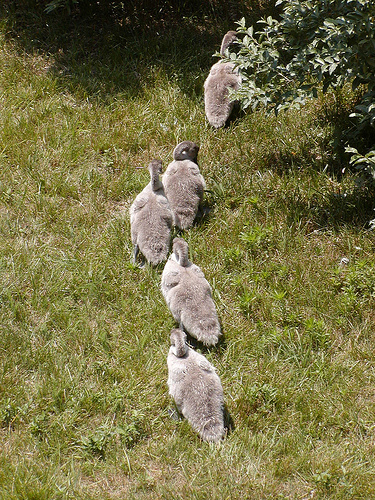<image>
Is there a duck behind the duck? Yes. From this viewpoint, the duck is positioned behind the duck, with the duck partially or fully occluding the duck. Where is the bird in relation to the bird? Is it in front of the bird? No. The bird is not in front of the bird. The spatial positioning shows a different relationship between these objects. Where is the duck in relation to the bush? Is it above the bush? No. The duck is not positioned above the bush. The vertical arrangement shows a different relationship. Where is the bird in relation to the grass? Is it above the grass? No. The bird is not positioned above the grass. The vertical arrangement shows a different relationship. 